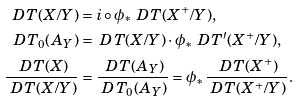<formula> <loc_0><loc_0><loc_500><loc_500>\ D T ( X / Y ) & = i \circ \phi _ { \ast } \ D T ( X ^ { + } / Y ) , \\ \ D T _ { 0 } ( A _ { Y } ) & = \ D T ( X / Y ) \cdot \phi _ { \ast } \ D T ^ { \prime } ( X ^ { + } / Y ) , \\ \frac { \ D T ( X ) } { \ D T ( X / Y ) } & = \frac { \ D T ( A _ { Y } ) } { \ D T _ { 0 } ( A _ { Y } ) } = \phi _ { \ast } \frac { \ D T ( X ^ { + } ) } { \ D T ( X ^ { + } / Y ) } .</formula> 